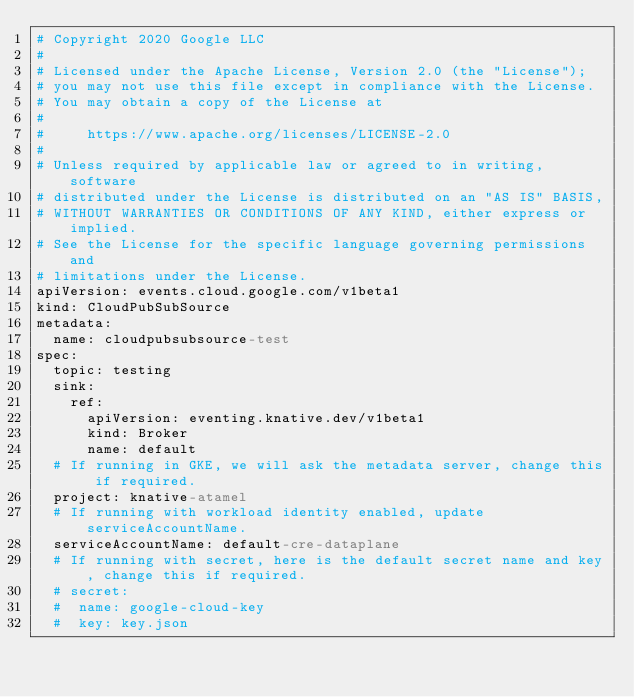Convert code to text. <code><loc_0><loc_0><loc_500><loc_500><_YAML_># Copyright 2020 Google LLC
#
# Licensed under the Apache License, Version 2.0 (the "License");
# you may not use this file except in compliance with the License.
# You may obtain a copy of the License at
#
#     https://www.apache.org/licenses/LICENSE-2.0
#
# Unless required by applicable law or agreed to in writing, software
# distributed under the License is distributed on an "AS IS" BASIS,
# WITHOUT WARRANTIES OR CONDITIONS OF ANY KIND, either express or implied.
# See the License for the specific language governing permissions and
# limitations under the License.
apiVersion: events.cloud.google.com/v1beta1
kind: CloudPubSubSource
metadata:
  name: cloudpubsubsource-test
spec:
  topic: testing
  sink:
    ref:
      apiVersion: eventing.knative.dev/v1beta1
      kind: Broker
      name: default
  # If running in GKE, we will ask the metadata server, change this if required.
  project: knative-atamel
  # If running with workload identity enabled, update serviceAccountName.
  serviceAccountName: default-cre-dataplane
  # If running with secret, here is the default secret name and key, change this if required.
  # secret:
  #  name: google-cloud-key
  #  key: key.json
</code> 